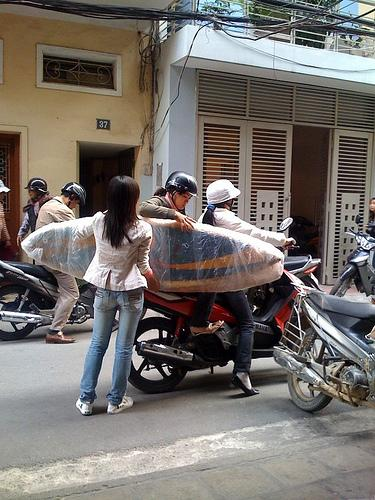What color is the background on the surfboard wrapped up with cello wrap? Please explain your reasoning. blue. It is the main color and orange is the accent color 